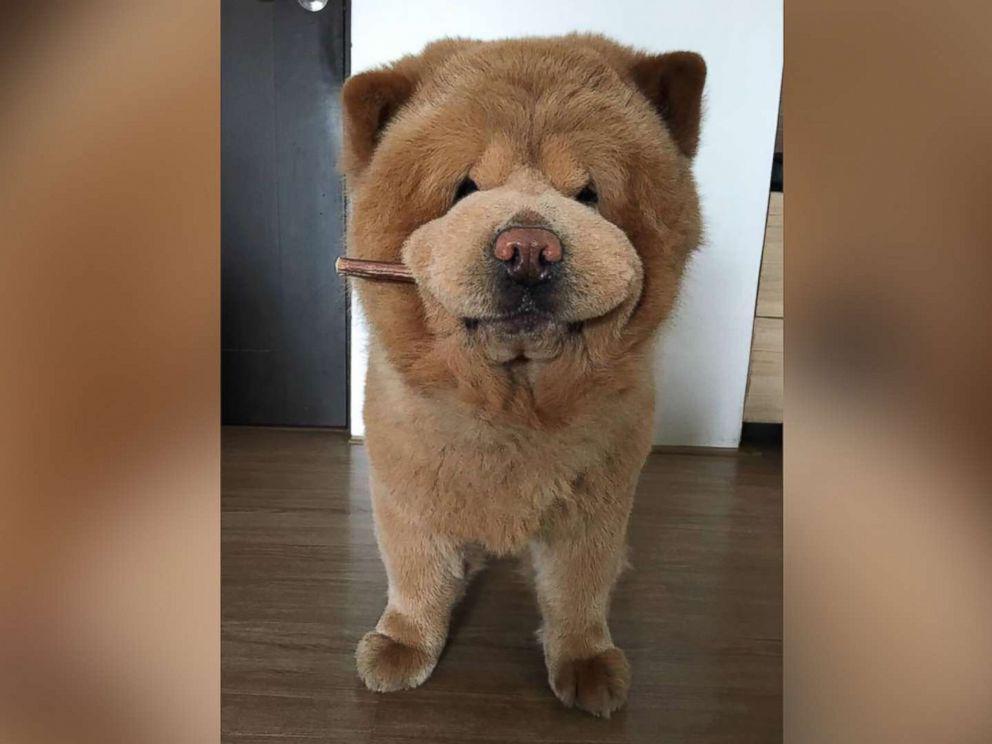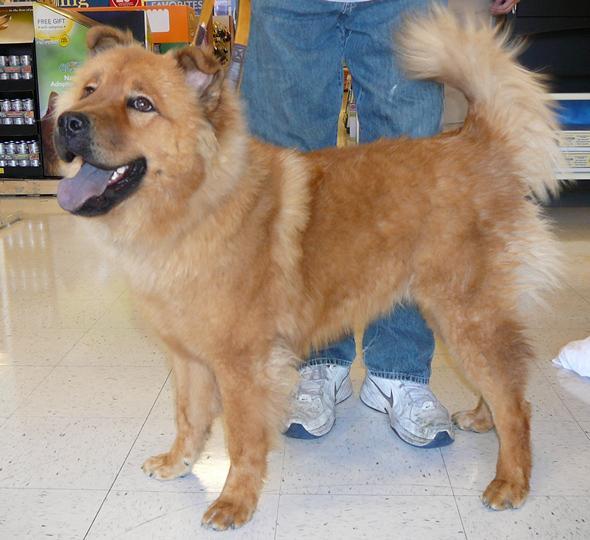The first image is the image on the left, the second image is the image on the right. For the images shown, is this caption "One dog is sitting and one is standing." true? Answer yes or no. No. 